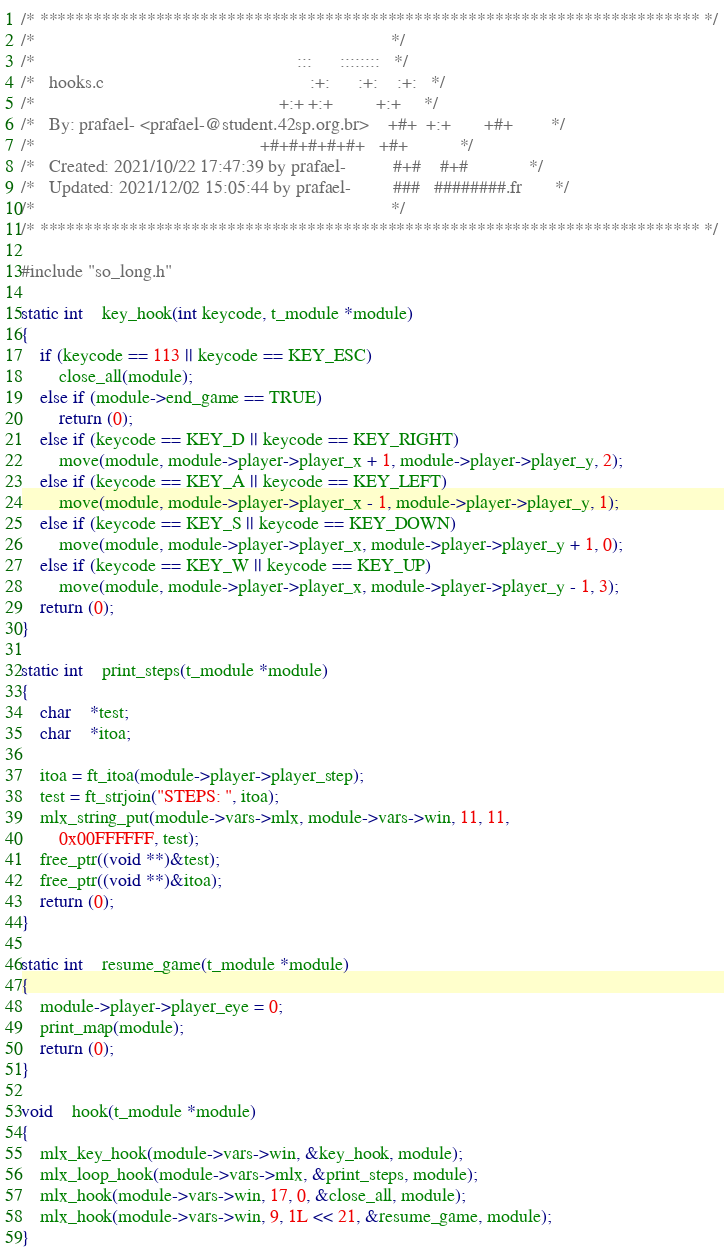<code> <loc_0><loc_0><loc_500><loc_500><_C_>/* ************************************************************************** */
/*                                                                            */
/*                                                        :::      ::::::::   */
/*   hooks.c                                            :+:      :+:    :+:   */
/*                                                    +:+ +:+         +:+     */
/*   By: prafael- <prafael-@student.42sp.org.br>    +#+  +:+       +#+        */
/*                                                +#+#+#+#+#+   +#+           */
/*   Created: 2021/10/22 17:47:39 by prafael-          #+#    #+#             */
/*   Updated: 2021/12/02 15:05:44 by prafael-         ###   ########.fr       */
/*                                                                            */
/* ************************************************************************** */

#include "so_long.h"

static int	key_hook(int keycode, t_module *module)
{
	if (keycode == 113 || keycode == KEY_ESC)
		close_all(module);
	else if (module->end_game == TRUE)
		return (0);
	else if (keycode == KEY_D || keycode == KEY_RIGHT)
		move(module, module->player->player_x + 1, module->player->player_y, 2);
	else if (keycode == KEY_A || keycode == KEY_LEFT)
		move(module, module->player->player_x - 1, module->player->player_y, 1);
	else if (keycode == KEY_S || keycode == KEY_DOWN)
		move(module, module->player->player_x, module->player->player_y + 1, 0);
	else if (keycode == KEY_W || keycode == KEY_UP)
		move(module, module->player->player_x, module->player->player_y - 1, 3);
	return (0);
}

static int	print_steps(t_module *module)
{
	char	*test;
	char	*itoa;

	itoa = ft_itoa(module->player->player_step);
	test = ft_strjoin("STEPS: ", itoa);
	mlx_string_put(module->vars->mlx, module->vars->win, 11, 11,
		0x00FFFFFF, test);
	free_ptr((void **)&test);
	free_ptr((void **)&itoa);
	return (0);
}

static int	resume_game(t_module *module)
{
	module->player->player_eye = 0;
	print_map(module);
	return (0);
}

void	hook(t_module *module)
{
	mlx_key_hook(module->vars->win, &key_hook, module);
	mlx_loop_hook(module->vars->mlx, &print_steps, module);
	mlx_hook(module->vars->win, 17, 0, &close_all, module);
	mlx_hook(module->vars->win, 9, 1L << 21, &resume_game, module);
}
</code> 